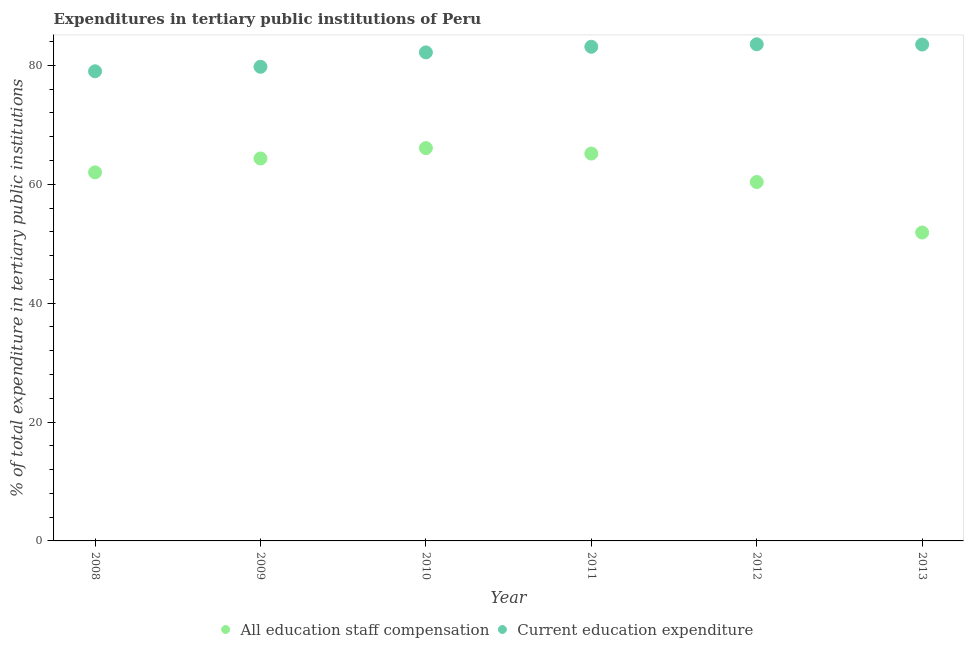How many different coloured dotlines are there?
Offer a very short reply. 2. Is the number of dotlines equal to the number of legend labels?
Give a very brief answer. Yes. What is the expenditure in staff compensation in 2008?
Your answer should be very brief. 61.99. Across all years, what is the maximum expenditure in education?
Ensure brevity in your answer.  83.54. Across all years, what is the minimum expenditure in staff compensation?
Ensure brevity in your answer.  51.88. In which year was the expenditure in staff compensation maximum?
Give a very brief answer. 2010. In which year was the expenditure in education minimum?
Provide a succinct answer. 2008. What is the total expenditure in staff compensation in the graph?
Offer a very short reply. 369.8. What is the difference between the expenditure in education in 2010 and that in 2011?
Keep it short and to the point. -0.95. What is the difference between the expenditure in staff compensation in 2011 and the expenditure in education in 2013?
Make the answer very short. -18.34. What is the average expenditure in education per year?
Your response must be concise. 81.85. In the year 2009, what is the difference between the expenditure in education and expenditure in staff compensation?
Offer a terse response. 15.42. What is the ratio of the expenditure in staff compensation in 2009 to that in 2012?
Keep it short and to the point. 1.07. What is the difference between the highest and the second highest expenditure in staff compensation?
Your response must be concise. 0.92. What is the difference between the highest and the lowest expenditure in staff compensation?
Your response must be concise. 14.2. In how many years, is the expenditure in staff compensation greater than the average expenditure in staff compensation taken over all years?
Provide a succinct answer. 4. Is the sum of the expenditure in education in 2011 and 2013 greater than the maximum expenditure in staff compensation across all years?
Your answer should be very brief. Yes. Is the expenditure in staff compensation strictly greater than the expenditure in education over the years?
Your response must be concise. No. How many dotlines are there?
Your answer should be very brief. 2. What is the difference between two consecutive major ticks on the Y-axis?
Your answer should be compact. 20. Are the values on the major ticks of Y-axis written in scientific E-notation?
Offer a terse response. No. Does the graph contain any zero values?
Ensure brevity in your answer.  No. Does the graph contain grids?
Your answer should be very brief. No. What is the title of the graph?
Your answer should be compact. Expenditures in tertiary public institutions of Peru. Does "GDP at market prices" appear as one of the legend labels in the graph?
Provide a short and direct response. No. What is the label or title of the Y-axis?
Keep it short and to the point. % of total expenditure in tertiary public institutions. What is the % of total expenditure in tertiary public institutions of All education staff compensation in 2008?
Give a very brief answer. 61.99. What is the % of total expenditure in tertiary public institutions of Current education expenditure in 2008?
Your answer should be very brief. 78.99. What is the % of total expenditure in tertiary public institutions in All education staff compensation in 2009?
Offer a very short reply. 64.33. What is the % of total expenditure in tertiary public institutions of Current education expenditure in 2009?
Your answer should be very brief. 79.75. What is the % of total expenditure in tertiary public institutions of All education staff compensation in 2010?
Make the answer very short. 66.08. What is the % of total expenditure in tertiary public institutions of Current education expenditure in 2010?
Your answer should be compact. 82.17. What is the % of total expenditure in tertiary public institutions in All education staff compensation in 2011?
Offer a terse response. 65.15. What is the % of total expenditure in tertiary public institutions in Current education expenditure in 2011?
Give a very brief answer. 83.12. What is the % of total expenditure in tertiary public institutions in All education staff compensation in 2012?
Offer a very short reply. 60.37. What is the % of total expenditure in tertiary public institutions in Current education expenditure in 2012?
Make the answer very short. 83.54. What is the % of total expenditure in tertiary public institutions of All education staff compensation in 2013?
Offer a very short reply. 51.88. What is the % of total expenditure in tertiary public institutions of Current education expenditure in 2013?
Ensure brevity in your answer.  83.49. Across all years, what is the maximum % of total expenditure in tertiary public institutions of All education staff compensation?
Offer a terse response. 66.08. Across all years, what is the maximum % of total expenditure in tertiary public institutions of Current education expenditure?
Ensure brevity in your answer.  83.54. Across all years, what is the minimum % of total expenditure in tertiary public institutions in All education staff compensation?
Keep it short and to the point. 51.88. Across all years, what is the minimum % of total expenditure in tertiary public institutions of Current education expenditure?
Give a very brief answer. 78.99. What is the total % of total expenditure in tertiary public institutions in All education staff compensation in the graph?
Your answer should be very brief. 369.8. What is the total % of total expenditure in tertiary public institutions of Current education expenditure in the graph?
Your answer should be compact. 491.07. What is the difference between the % of total expenditure in tertiary public institutions in All education staff compensation in 2008 and that in 2009?
Your answer should be very brief. -2.34. What is the difference between the % of total expenditure in tertiary public institutions in Current education expenditure in 2008 and that in 2009?
Provide a short and direct response. -0.76. What is the difference between the % of total expenditure in tertiary public institutions of All education staff compensation in 2008 and that in 2010?
Your response must be concise. -4.08. What is the difference between the % of total expenditure in tertiary public institutions in Current education expenditure in 2008 and that in 2010?
Give a very brief answer. -3.18. What is the difference between the % of total expenditure in tertiary public institutions of All education staff compensation in 2008 and that in 2011?
Provide a short and direct response. -3.16. What is the difference between the % of total expenditure in tertiary public institutions of Current education expenditure in 2008 and that in 2011?
Ensure brevity in your answer.  -4.13. What is the difference between the % of total expenditure in tertiary public institutions of All education staff compensation in 2008 and that in 2012?
Keep it short and to the point. 1.63. What is the difference between the % of total expenditure in tertiary public institutions of Current education expenditure in 2008 and that in 2012?
Provide a short and direct response. -4.54. What is the difference between the % of total expenditure in tertiary public institutions in All education staff compensation in 2008 and that in 2013?
Your response must be concise. 10.12. What is the difference between the % of total expenditure in tertiary public institutions in Current education expenditure in 2008 and that in 2013?
Make the answer very short. -4.5. What is the difference between the % of total expenditure in tertiary public institutions of All education staff compensation in 2009 and that in 2010?
Your answer should be compact. -1.75. What is the difference between the % of total expenditure in tertiary public institutions in Current education expenditure in 2009 and that in 2010?
Make the answer very short. -2.42. What is the difference between the % of total expenditure in tertiary public institutions of All education staff compensation in 2009 and that in 2011?
Give a very brief answer. -0.82. What is the difference between the % of total expenditure in tertiary public institutions in Current education expenditure in 2009 and that in 2011?
Your response must be concise. -3.37. What is the difference between the % of total expenditure in tertiary public institutions of All education staff compensation in 2009 and that in 2012?
Ensure brevity in your answer.  3.96. What is the difference between the % of total expenditure in tertiary public institutions in Current education expenditure in 2009 and that in 2012?
Offer a very short reply. -3.79. What is the difference between the % of total expenditure in tertiary public institutions in All education staff compensation in 2009 and that in 2013?
Your answer should be compact. 12.45. What is the difference between the % of total expenditure in tertiary public institutions of Current education expenditure in 2009 and that in 2013?
Provide a succinct answer. -3.74. What is the difference between the % of total expenditure in tertiary public institutions in All education staff compensation in 2010 and that in 2011?
Your answer should be compact. 0.92. What is the difference between the % of total expenditure in tertiary public institutions in Current education expenditure in 2010 and that in 2011?
Offer a terse response. -0.95. What is the difference between the % of total expenditure in tertiary public institutions of All education staff compensation in 2010 and that in 2012?
Ensure brevity in your answer.  5.71. What is the difference between the % of total expenditure in tertiary public institutions in Current education expenditure in 2010 and that in 2012?
Make the answer very short. -1.37. What is the difference between the % of total expenditure in tertiary public institutions of All education staff compensation in 2010 and that in 2013?
Provide a short and direct response. 14.2. What is the difference between the % of total expenditure in tertiary public institutions of Current education expenditure in 2010 and that in 2013?
Your response must be concise. -1.32. What is the difference between the % of total expenditure in tertiary public institutions in All education staff compensation in 2011 and that in 2012?
Provide a succinct answer. 4.79. What is the difference between the % of total expenditure in tertiary public institutions of Current education expenditure in 2011 and that in 2012?
Your answer should be compact. -0.42. What is the difference between the % of total expenditure in tertiary public institutions in All education staff compensation in 2011 and that in 2013?
Offer a terse response. 13.28. What is the difference between the % of total expenditure in tertiary public institutions of Current education expenditure in 2011 and that in 2013?
Your response must be concise. -0.37. What is the difference between the % of total expenditure in tertiary public institutions of All education staff compensation in 2012 and that in 2013?
Your answer should be very brief. 8.49. What is the difference between the % of total expenditure in tertiary public institutions in Current education expenditure in 2012 and that in 2013?
Your response must be concise. 0.04. What is the difference between the % of total expenditure in tertiary public institutions of All education staff compensation in 2008 and the % of total expenditure in tertiary public institutions of Current education expenditure in 2009?
Provide a succinct answer. -17.76. What is the difference between the % of total expenditure in tertiary public institutions in All education staff compensation in 2008 and the % of total expenditure in tertiary public institutions in Current education expenditure in 2010?
Provide a short and direct response. -20.18. What is the difference between the % of total expenditure in tertiary public institutions in All education staff compensation in 2008 and the % of total expenditure in tertiary public institutions in Current education expenditure in 2011?
Your answer should be compact. -21.13. What is the difference between the % of total expenditure in tertiary public institutions of All education staff compensation in 2008 and the % of total expenditure in tertiary public institutions of Current education expenditure in 2012?
Ensure brevity in your answer.  -21.54. What is the difference between the % of total expenditure in tertiary public institutions in All education staff compensation in 2008 and the % of total expenditure in tertiary public institutions in Current education expenditure in 2013?
Provide a short and direct response. -21.5. What is the difference between the % of total expenditure in tertiary public institutions in All education staff compensation in 2009 and the % of total expenditure in tertiary public institutions in Current education expenditure in 2010?
Your response must be concise. -17.84. What is the difference between the % of total expenditure in tertiary public institutions of All education staff compensation in 2009 and the % of total expenditure in tertiary public institutions of Current education expenditure in 2011?
Make the answer very short. -18.79. What is the difference between the % of total expenditure in tertiary public institutions in All education staff compensation in 2009 and the % of total expenditure in tertiary public institutions in Current education expenditure in 2012?
Offer a terse response. -19.21. What is the difference between the % of total expenditure in tertiary public institutions of All education staff compensation in 2009 and the % of total expenditure in tertiary public institutions of Current education expenditure in 2013?
Your response must be concise. -19.16. What is the difference between the % of total expenditure in tertiary public institutions of All education staff compensation in 2010 and the % of total expenditure in tertiary public institutions of Current education expenditure in 2011?
Offer a terse response. -17.04. What is the difference between the % of total expenditure in tertiary public institutions in All education staff compensation in 2010 and the % of total expenditure in tertiary public institutions in Current education expenditure in 2012?
Ensure brevity in your answer.  -17.46. What is the difference between the % of total expenditure in tertiary public institutions in All education staff compensation in 2010 and the % of total expenditure in tertiary public institutions in Current education expenditure in 2013?
Your answer should be compact. -17.42. What is the difference between the % of total expenditure in tertiary public institutions in All education staff compensation in 2011 and the % of total expenditure in tertiary public institutions in Current education expenditure in 2012?
Your answer should be very brief. -18.38. What is the difference between the % of total expenditure in tertiary public institutions in All education staff compensation in 2011 and the % of total expenditure in tertiary public institutions in Current education expenditure in 2013?
Provide a short and direct response. -18.34. What is the difference between the % of total expenditure in tertiary public institutions of All education staff compensation in 2012 and the % of total expenditure in tertiary public institutions of Current education expenditure in 2013?
Offer a terse response. -23.13. What is the average % of total expenditure in tertiary public institutions in All education staff compensation per year?
Your answer should be compact. 61.63. What is the average % of total expenditure in tertiary public institutions in Current education expenditure per year?
Keep it short and to the point. 81.85. In the year 2008, what is the difference between the % of total expenditure in tertiary public institutions of All education staff compensation and % of total expenditure in tertiary public institutions of Current education expenditure?
Give a very brief answer. -17. In the year 2009, what is the difference between the % of total expenditure in tertiary public institutions of All education staff compensation and % of total expenditure in tertiary public institutions of Current education expenditure?
Provide a succinct answer. -15.42. In the year 2010, what is the difference between the % of total expenditure in tertiary public institutions of All education staff compensation and % of total expenditure in tertiary public institutions of Current education expenditure?
Ensure brevity in your answer.  -16.1. In the year 2011, what is the difference between the % of total expenditure in tertiary public institutions in All education staff compensation and % of total expenditure in tertiary public institutions in Current education expenditure?
Your response must be concise. -17.97. In the year 2012, what is the difference between the % of total expenditure in tertiary public institutions of All education staff compensation and % of total expenditure in tertiary public institutions of Current education expenditure?
Make the answer very short. -23.17. In the year 2013, what is the difference between the % of total expenditure in tertiary public institutions of All education staff compensation and % of total expenditure in tertiary public institutions of Current education expenditure?
Ensure brevity in your answer.  -31.62. What is the ratio of the % of total expenditure in tertiary public institutions in All education staff compensation in 2008 to that in 2009?
Provide a succinct answer. 0.96. What is the ratio of the % of total expenditure in tertiary public institutions of Current education expenditure in 2008 to that in 2009?
Keep it short and to the point. 0.99. What is the ratio of the % of total expenditure in tertiary public institutions in All education staff compensation in 2008 to that in 2010?
Ensure brevity in your answer.  0.94. What is the ratio of the % of total expenditure in tertiary public institutions in Current education expenditure in 2008 to that in 2010?
Your response must be concise. 0.96. What is the ratio of the % of total expenditure in tertiary public institutions in All education staff compensation in 2008 to that in 2011?
Provide a succinct answer. 0.95. What is the ratio of the % of total expenditure in tertiary public institutions of Current education expenditure in 2008 to that in 2011?
Offer a very short reply. 0.95. What is the ratio of the % of total expenditure in tertiary public institutions in All education staff compensation in 2008 to that in 2012?
Your response must be concise. 1.03. What is the ratio of the % of total expenditure in tertiary public institutions in Current education expenditure in 2008 to that in 2012?
Your answer should be very brief. 0.95. What is the ratio of the % of total expenditure in tertiary public institutions in All education staff compensation in 2008 to that in 2013?
Provide a succinct answer. 1.2. What is the ratio of the % of total expenditure in tertiary public institutions of Current education expenditure in 2008 to that in 2013?
Make the answer very short. 0.95. What is the ratio of the % of total expenditure in tertiary public institutions in All education staff compensation in 2009 to that in 2010?
Offer a terse response. 0.97. What is the ratio of the % of total expenditure in tertiary public institutions of Current education expenditure in 2009 to that in 2010?
Your response must be concise. 0.97. What is the ratio of the % of total expenditure in tertiary public institutions of All education staff compensation in 2009 to that in 2011?
Make the answer very short. 0.99. What is the ratio of the % of total expenditure in tertiary public institutions of Current education expenditure in 2009 to that in 2011?
Offer a terse response. 0.96. What is the ratio of the % of total expenditure in tertiary public institutions of All education staff compensation in 2009 to that in 2012?
Give a very brief answer. 1.07. What is the ratio of the % of total expenditure in tertiary public institutions of Current education expenditure in 2009 to that in 2012?
Your answer should be very brief. 0.95. What is the ratio of the % of total expenditure in tertiary public institutions in All education staff compensation in 2009 to that in 2013?
Provide a short and direct response. 1.24. What is the ratio of the % of total expenditure in tertiary public institutions of Current education expenditure in 2009 to that in 2013?
Ensure brevity in your answer.  0.96. What is the ratio of the % of total expenditure in tertiary public institutions of All education staff compensation in 2010 to that in 2011?
Offer a very short reply. 1.01. What is the ratio of the % of total expenditure in tertiary public institutions in All education staff compensation in 2010 to that in 2012?
Ensure brevity in your answer.  1.09. What is the ratio of the % of total expenditure in tertiary public institutions in Current education expenditure in 2010 to that in 2012?
Give a very brief answer. 0.98. What is the ratio of the % of total expenditure in tertiary public institutions in All education staff compensation in 2010 to that in 2013?
Keep it short and to the point. 1.27. What is the ratio of the % of total expenditure in tertiary public institutions in Current education expenditure in 2010 to that in 2013?
Give a very brief answer. 0.98. What is the ratio of the % of total expenditure in tertiary public institutions of All education staff compensation in 2011 to that in 2012?
Keep it short and to the point. 1.08. What is the ratio of the % of total expenditure in tertiary public institutions of Current education expenditure in 2011 to that in 2012?
Your answer should be very brief. 0.99. What is the ratio of the % of total expenditure in tertiary public institutions in All education staff compensation in 2011 to that in 2013?
Make the answer very short. 1.26. What is the ratio of the % of total expenditure in tertiary public institutions in All education staff compensation in 2012 to that in 2013?
Ensure brevity in your answer.  1.16. What is the ratio of the % of total expenditure in tertiary public institutions in Current education expenditure in 2012 to that in 2013?
Provide a succinct answer. 1. What is the difference between the highest and the second highest % of total expenditure in tertiary public institutions of All education staff compensation?
Your answer should be compact. 0.92. What is the difference between the highest and the second highest % of total expenditure in tertiary public institutions in Current education expenditure?
Keep it short and to the point. 0.04. What is the difference between the highest and the lowest % of total expenditure in tertiary public institutions of All education staff compensation?
Offer a terse response. 14.2. What is the difference between the highest and the lowest % of total expenditure in tertiary public institutions of Current education expenditure?
Your response must be concise. 4.54. 